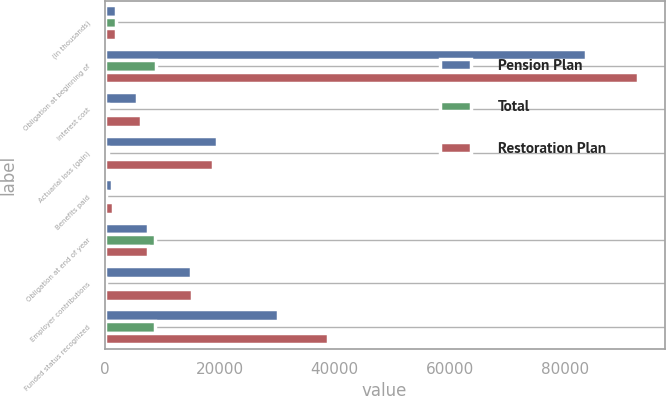Convert chart to OTSL. <chart><loc_0><loc_0><loc_500><loc_500><stacked_bar_chart><ecel><fcel>(In thousands)<fcel>Obligation at beginning of<fcel>Interest cost<fcel>Actuarial loss (gain)<fcel>Benefits paid<fcel>Obligation at end of year<fcel>Employer contributions<fcel>Funded status recognized<nl><fcel>Pension Plan<fcel>2010<fcel>83766<fcel>5710<fcel>19540<fcel>1214<fcel>7503<fcel>15036<fcel>30079<nl><fcel>Total<fcel>2010<fcel>8930<fcel>605<fcel>671<fcel>173<fcel>8691<fcel>173<fcel>8691<nl><fcel>Restoration Plan<fcel>2010<fcel>92696<fcel>6315<fcel>18869<fcel>1387<fcel>7503<fcel>15209<fcel>38770<nl></chart> 